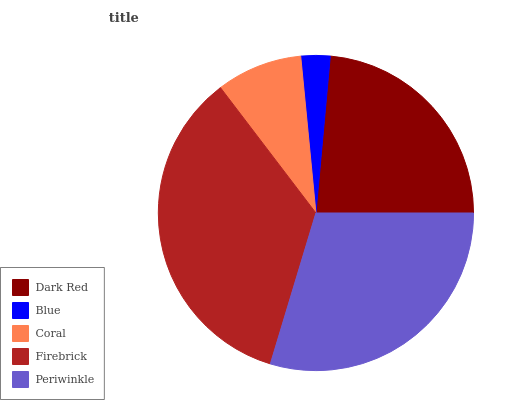Is Blue the minimum?
Answer yes or no. Yes. Is Firebrick the maximum?
Answer yes or no. Yes. Is Coral the minimum?
Answer yes or no. No. Is Coral the maximum?
Answer yes or no. No. Is Coral greater than Blue?
Answer yes or no. Yes. Is Blue less than Coral?
Answer yes or no. Yes. Is Blue greater than Coral?
Answer yes or no. No. Is Coral less than Blue?
Answer yes or no. No. Is Dark Red the high median?
Answer yes or no. Yes. Is Dark Red the low median?
Answer yes or no. Yes. Is Coral the high median?
Answer yes or no. No. Is Blue the low median?
Answer yes or no. No. 